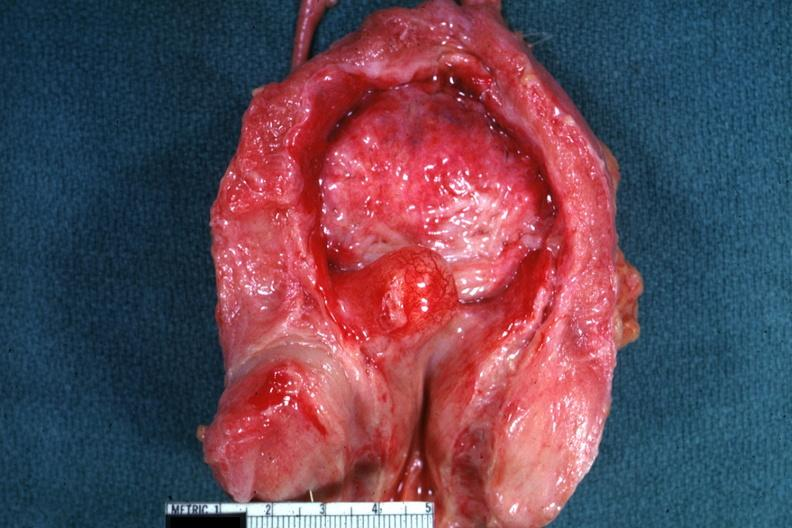does this image show opened urinary bladder with median lobe protruding into floor of bladder?
Answer the question using a single word or phrase. Yes 